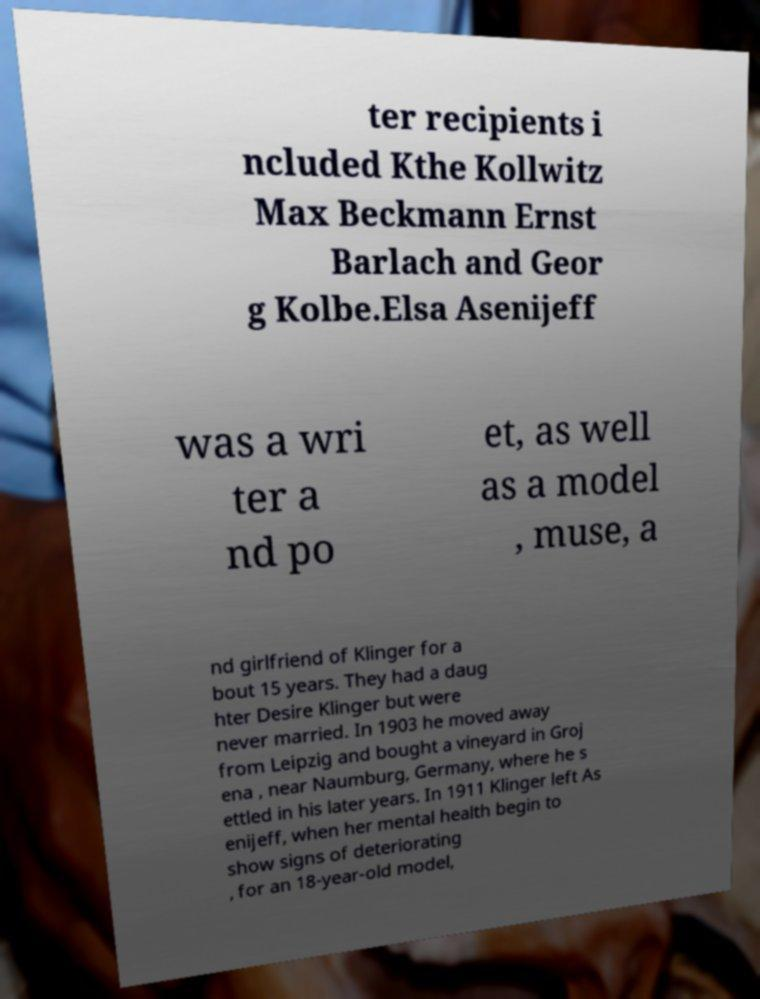There's text embedded in this image that I need extracted. Can you transcribe it verbatim? ter recipients i ncluded Kthe Kollwitz Max Beckmann Ernst Barlach and Geor g Kolbe.Elsa Asenijeff was a wri ter a nd po et, as well as a model , muse, a nd girlfriend of Klinger for a bout 15 years. They had a daug hter Desire Klinger but were never married. In 1903 he moved away from Leipzig and bought a vineyard in Groj ena , near Naumburg, Germany, where he s ettled in his later years. In 1911 Klinger left As enijeff, when her mental health begin to show signs of deteriorating , for an 18-year-old model, 